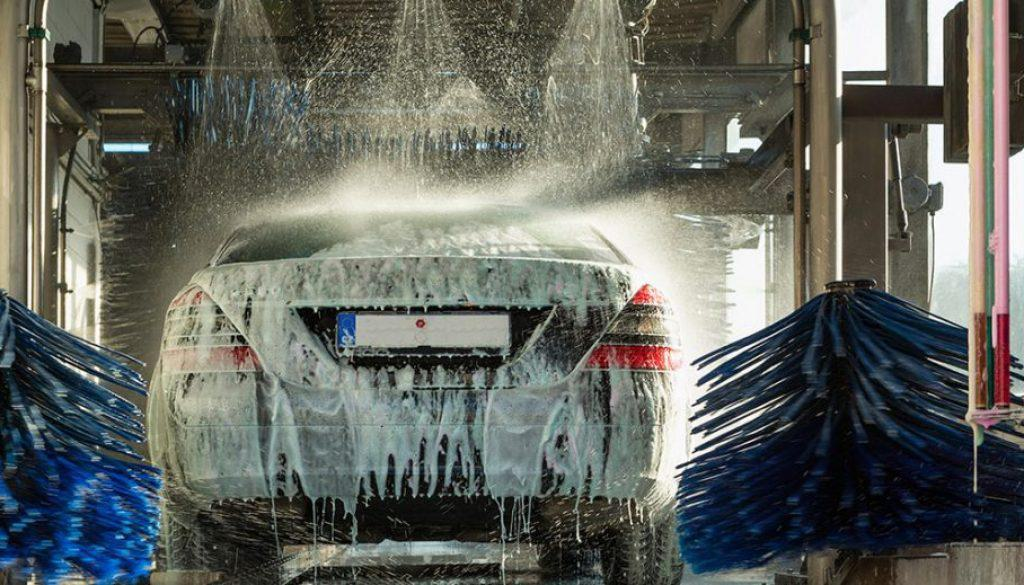Can you tell if the car wash is indoor or outdoor? The car wash is set up indoors, as evidenced by the structure's interior lighting and the enclosed space surrounding the vehicle and washing equipment. 